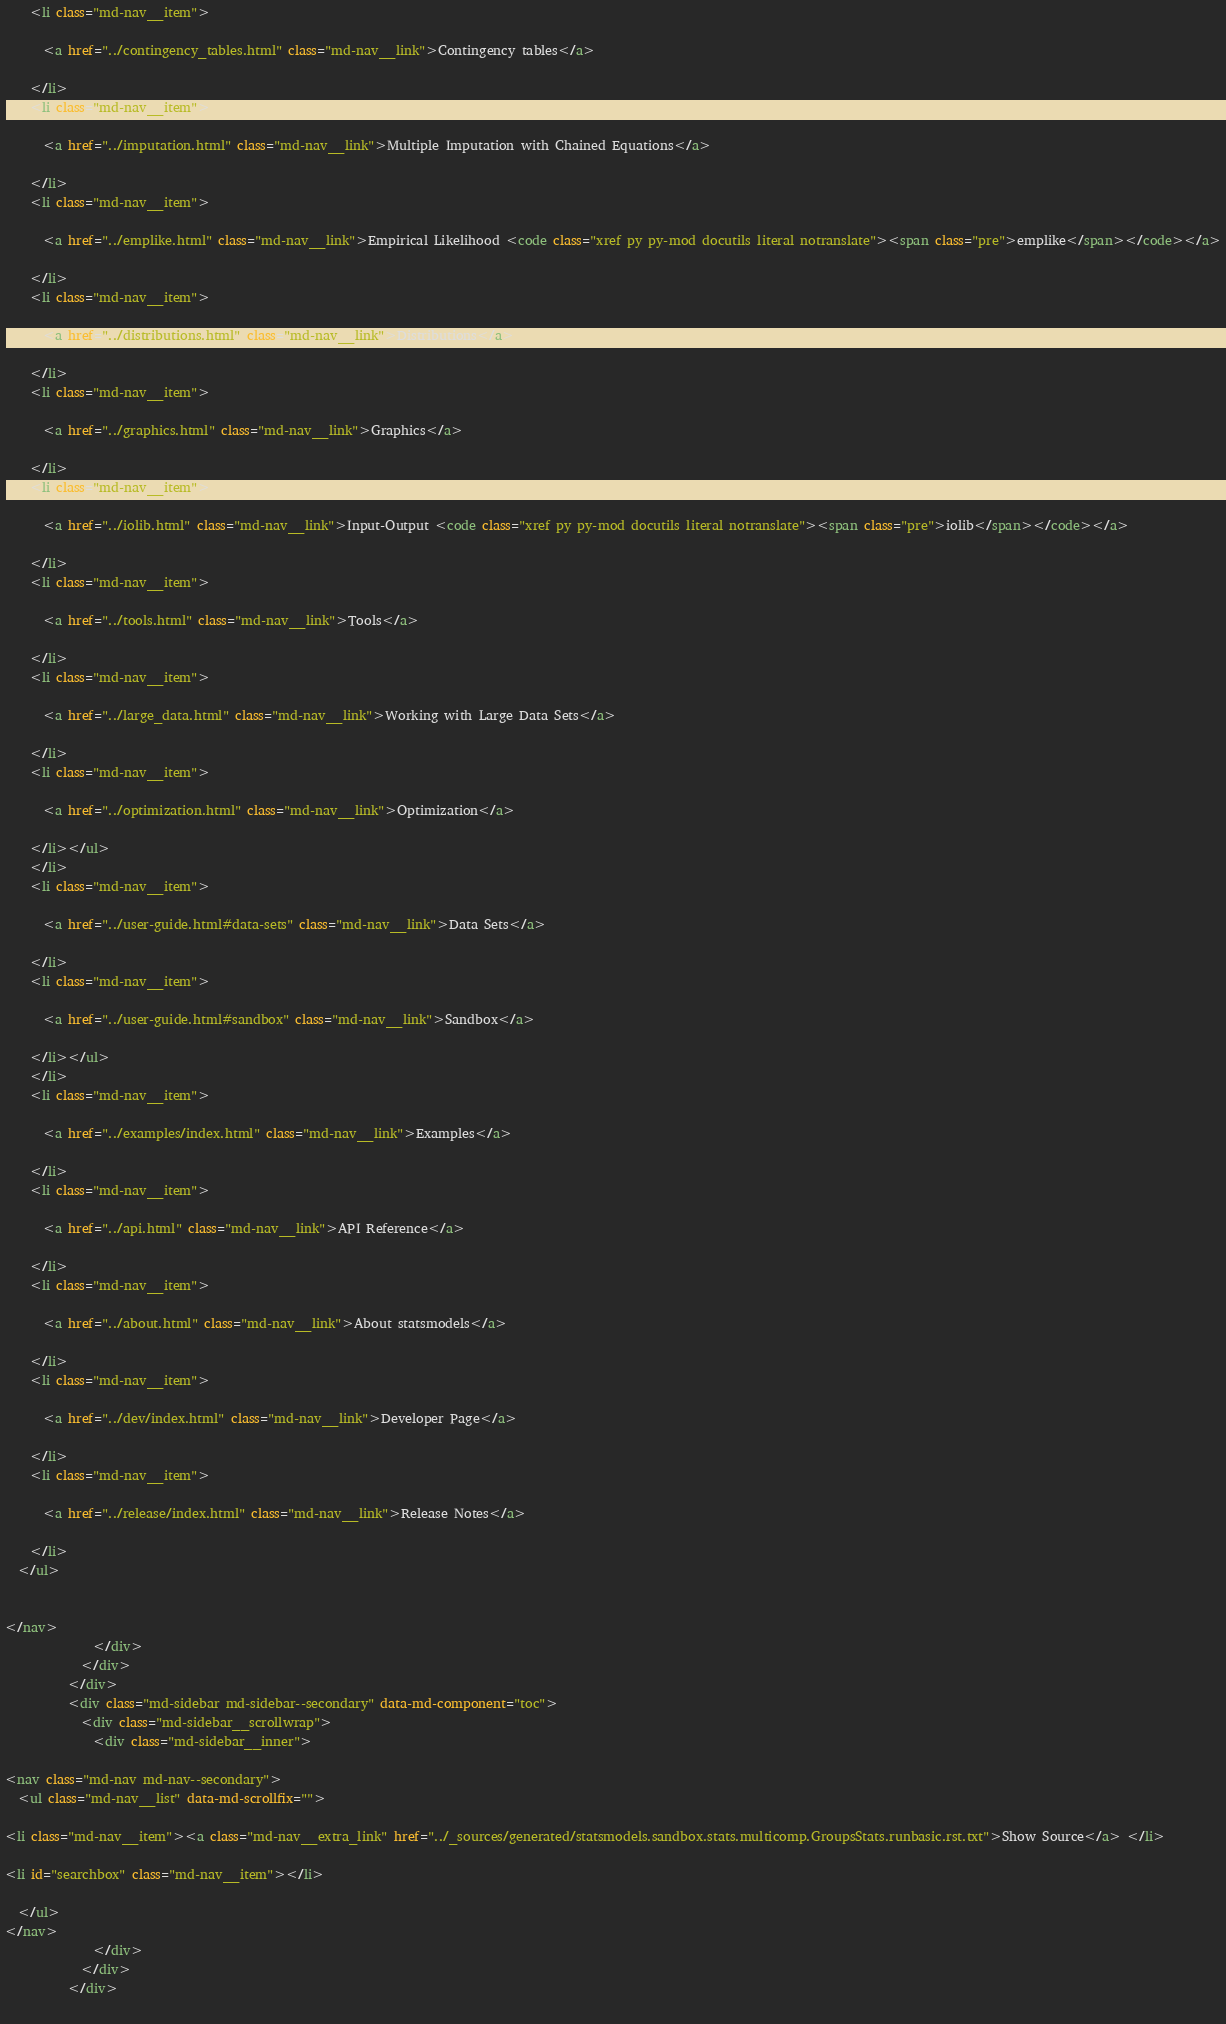<code> <loc_0><loc_0><loc_500><loc_500><_HTML_>    <li class="md-nav__item">
    
      <a href="../contingency_tables.html" class="md-nav__link">Contingency tables</a>
      
    </li>
    <li class="md-nav__item">
    
      <a href="../imputation.html" class="md-nav__link">Multiple Imputation with Chained Equations</a>
      
    </li>
    <li class="md-nav__item">
    
      <a href="../emplike.html" class="md-nav__link">Empirical Likelihood <code class="xref py py-mod docutils literal notranslate"><span class="pre">emplike</span></code></a>
      
    </li>
    <li class="md-nav__item">
    
      <a href="../distributions.html" class="md-nav__link">Distributions</a>
      
    </li>
    <li class="md-nav__item">
    
      <a href="../graphics.html" class="md-nav__link">Graphics</a>
      
    </li>
    <li class="md-nav__item">
    
      <a href="../iolib.html" class="md-nav__link">Input-Output <code class="xref py py-mod docutils literal notranslate"><span class="pre">iolib</span></code></a>
      
    </li>
    <li class="md-nav__item">
    
      <a href="../tools.html" class="md-nav__link">Tools</a>
      
    </li>
    <li class="md-nav__item">
    
      <a href="../large_data.html" class="md-nav__link">Working with Large Data Sets</a>
      
    </li>
    <li class="md-nav__item">
    
      <a href="../optimization.html" class="md-nav__link">Optimization</a>
      
    </li></ul>
    </li>
    <li class="md-nav__item">
    
      <a href="../user-guide.html#data-sets" class="md-nav__link">Data Sets</a>
      
    </li>
    <li class="md-nav__item">
    
      <a href="../user-guide.html#sandbox" class="md-nav__link">Sandbox</a>
      
    </li></ul>
    </li>
    <li class="md-nav__item">
    
      <a href="../examples/index.html" class="md-nav__link">Examples</a>
      
    </li>
    <li class="md-nav__item">
    
      <a href="../api.html" class="md-nav__link">API Reference</a>
      
    </li>
    <li class="md-nav__item">
    
      <a href="../about.html" class="md-nav__link">About statsmodels</a>
      
    </li>
    <li class="md-nav__item">
    
      <a href="../dev/index.html" class="md-nav__link">Developer Page</a>
      
    </li>
    <li class="md-nav__item">
    
      <a href="../release/index.html" class="md-nav__link">Release Notes</a>
      
    </li>
  </ul>
  

</nav>
              </div>
            </div>
          </div>
          <div class="md-sidebar md-sidebar--secondary" data-md-component="toc">
            <div class="md-sidebar__scrollwrap">
              <div class="md-sidebar__inner">
                
<nav class="md-nav md-nav--secondary">
  <ul class="md-nav__list" data-md-scrollfix="">
    
<li class="md-nav__item"><a class="md-nav__extra_link" href="../_sources/generated/statsmodels.sandbox.stats.multicomp.GroupsStats.runbasic.rst.txt">Show Source</a> </li>

<li id="searchbox" class="md-nav__item"></li>

  </ul>
</nav>
              </div>
            </div>
          </div>
        </code> 